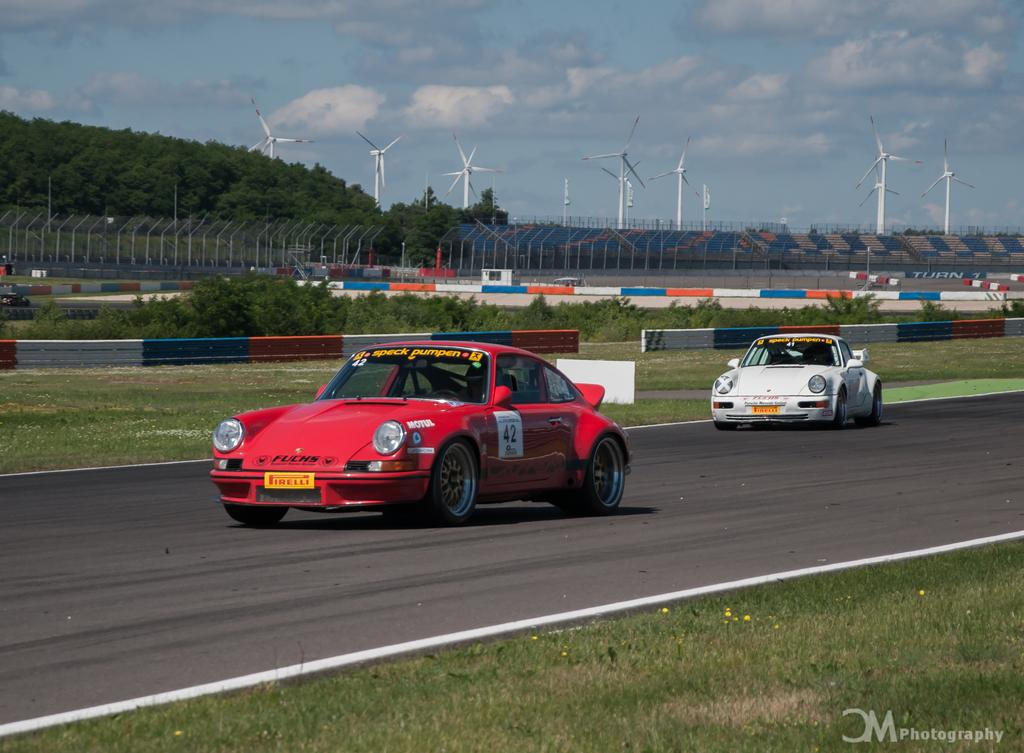What is happening in the foreground of the image? There are two cars moving on the road in the foreground of the image. What can be seen on either side of the road? There are trees and fencing poles on either side of the road. What structure is visible in the image? There is a stadium visible in the image. What objects are present near the stadium? Wind fans are present in the image. What is visible in the background of the image? The sky is visible in the image, and clouds are present in the sky. What type of holiday is being celebrated in the image? There is no indication of a holiday being celebrated in the image. Can you see a goose flying in the sky in the image? There is no goose present in the image; only cars, trees, fencing poles, a stadium, wind fans, and the sky with clouds are visible. 